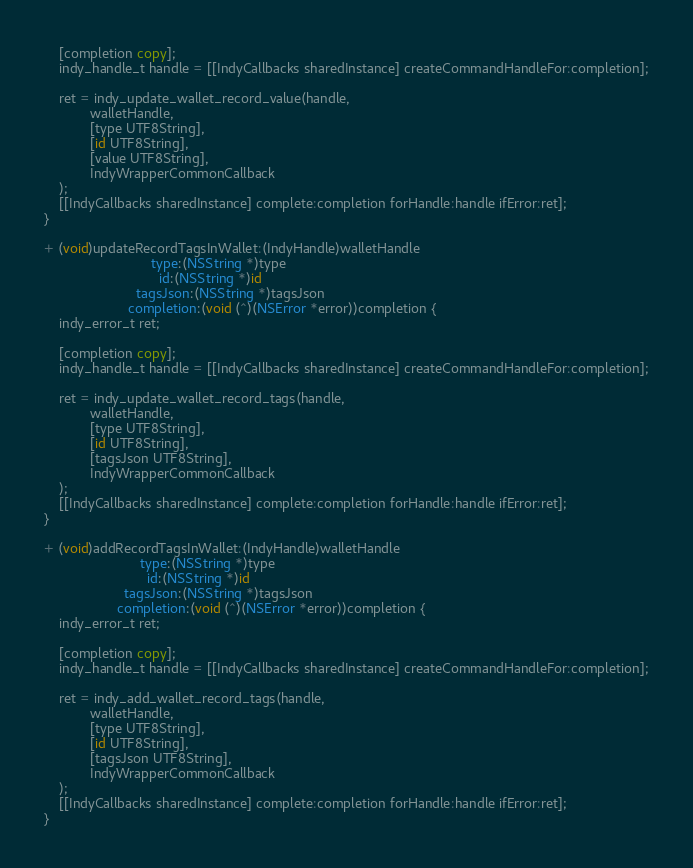<code> <loc_0><loc_0><loc_500><loc_500><_ObjectiveC_>    [completion copy];
    indy_handle_t handle = [[IndyCallbacks sharedInstance] createCommandHandleFor:completion];

    ret = indy_update_wallet_record_value(handle,
            walletHandle,
            [type UTF8String],
            [id UTF8String],
            [value UTF8String],
            IndyWrapperCommonCallback
    );
    [[IndyCallbacks sharedInstance] complete:completion forHandle:handle ifError:ret];
}

+ (void)updateRecordTagsInWallet:(IndyHandle)walletHandle
                            type:(NSString *)type
                              id:(NSString *)id
                        tagsJson:(NSString *)tagsJson
                      completion:(void (^)(NSError *error))completion {
    indy_error_t ret;

    [completion copy];
    indy_handle_t handle = [[IndyCallbacks sharedInstance] createCommandHandleFor:completion];

    ret = indy_update_wallet_record_tags(handle,
            walletHandle,
            [type UTF8String],
            [id UTF8String],
            [tagsJson UTF8String],
            IndyWrapperCommonCallback
    );
    [[IndyCallbacks sharedInstance] complete:completion forHandle:handle ifError:ret];
}

+ (void)addRecordTagsInWallet:(IndyHandle)walletHandle
                         type:(NSString *)type
                           id:(NSString *)id
                     tagsJson:(NSString *)tagsJson
                   completion:(void (^)(NSError *error))completion {
    indy_error_t ret;

    [completion copy];
    indy_handle_t handle = [[IndyCallbacks sharedInstance] createCommandHandleFor:completion];

    ret = indy_add_wallet_record_tags(handle,
            walletHandle,
            [type UTF8String],
            [id UTF8String],
            [tagsJson UTF8String],
            IndyWrapperCommonCallback
    );
    [[IndyCallbacks sharedInstance] complete:completion forHandle:handle ifError:ret];
}
</code> 